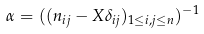Convert formula to latex. <formula><loc_0><loc_0><loc_500><loc_500>\alpha = ( ( n _ { i j } - X \delta _ { i j } ) _ { 1 \leq i , j \leq n } ) ^ { - 1 }</formula> 